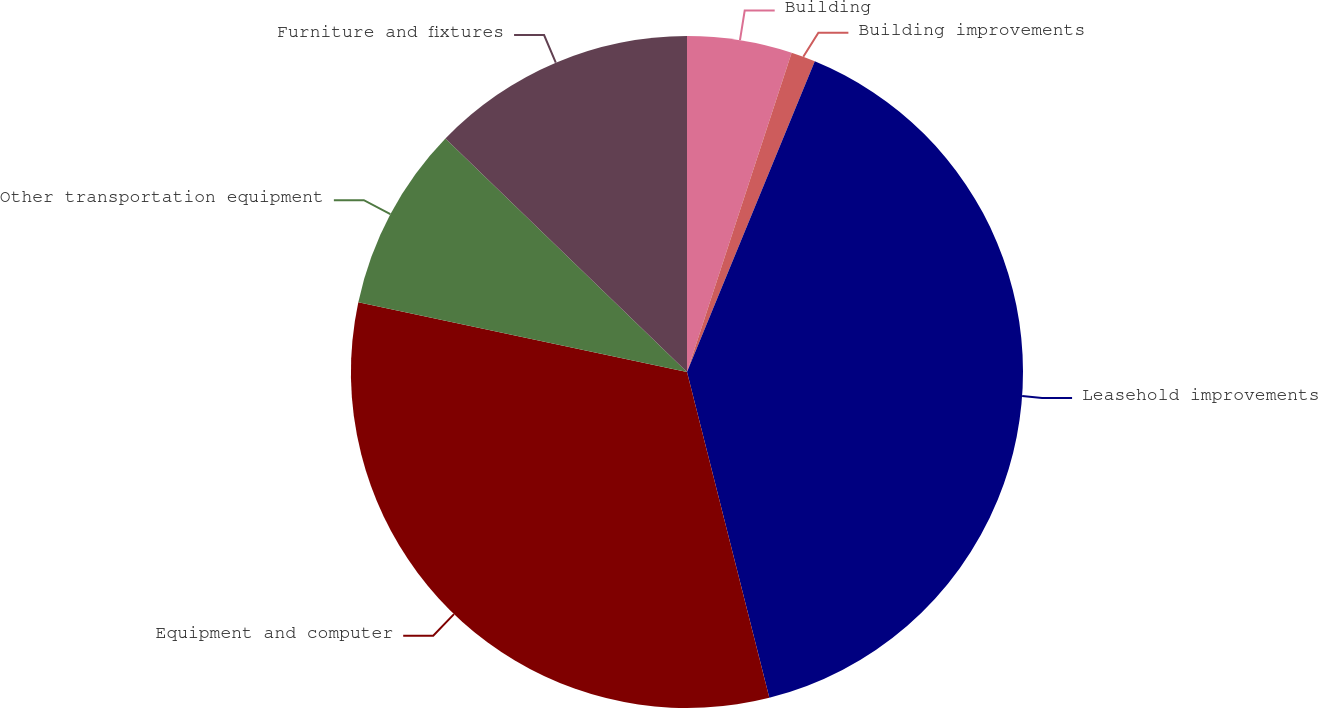Convert chart to OTSL. <chart><loc_0><loc_0><loc_500><loc_500><pie_chart><fcel>Building<fcel>Building improvements<fcel>Leasehold improvements<fcel>Equipment and computer<fcel>Other transportation equipment<fcel>Furniture and fixtures<nl><fcel>5.04%<fcel>1.17%<fcel>39.85%<fcel>32.27%<fcel>8.9%<fcel>12.77%<nl></chart> 